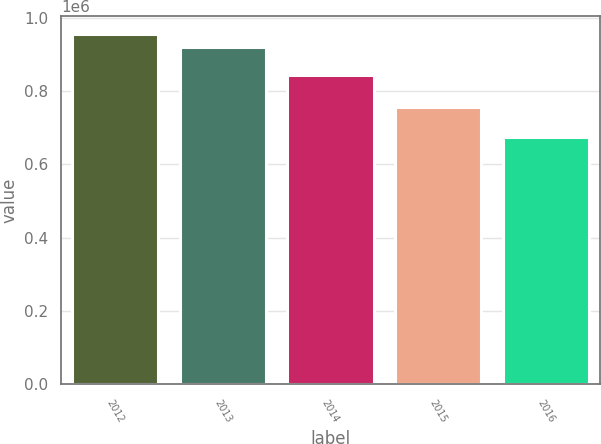Convert chart. <chart><loc_0><loc_0><loc_500><loc_500><bar_chart><fcel>2012<fcel>2013<fcel>2014<fcel>2015<fcel>2016<nl><fcel>955920<fcel>919388<fcel>843069<fcel>755334<fcel>673792<nl></chart> 